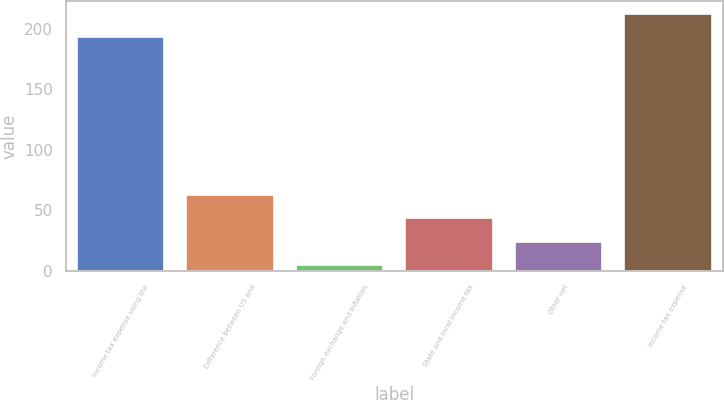Convert chart. <chart><loc_0><loc_0><loc_500><loc_500><bar_chart><fcel>Income tax expense using the<fcel>Difference between US and<fcel>Foreign exchange and inflation<fcel>State and local income tax<fcel>Other net<fcel>Income tax expense<nl><fcel>193.1<fcel>62.78<fcel>4.7<fcel>43.42<fcel>24.06<fcel>212.46<nl></chart> 